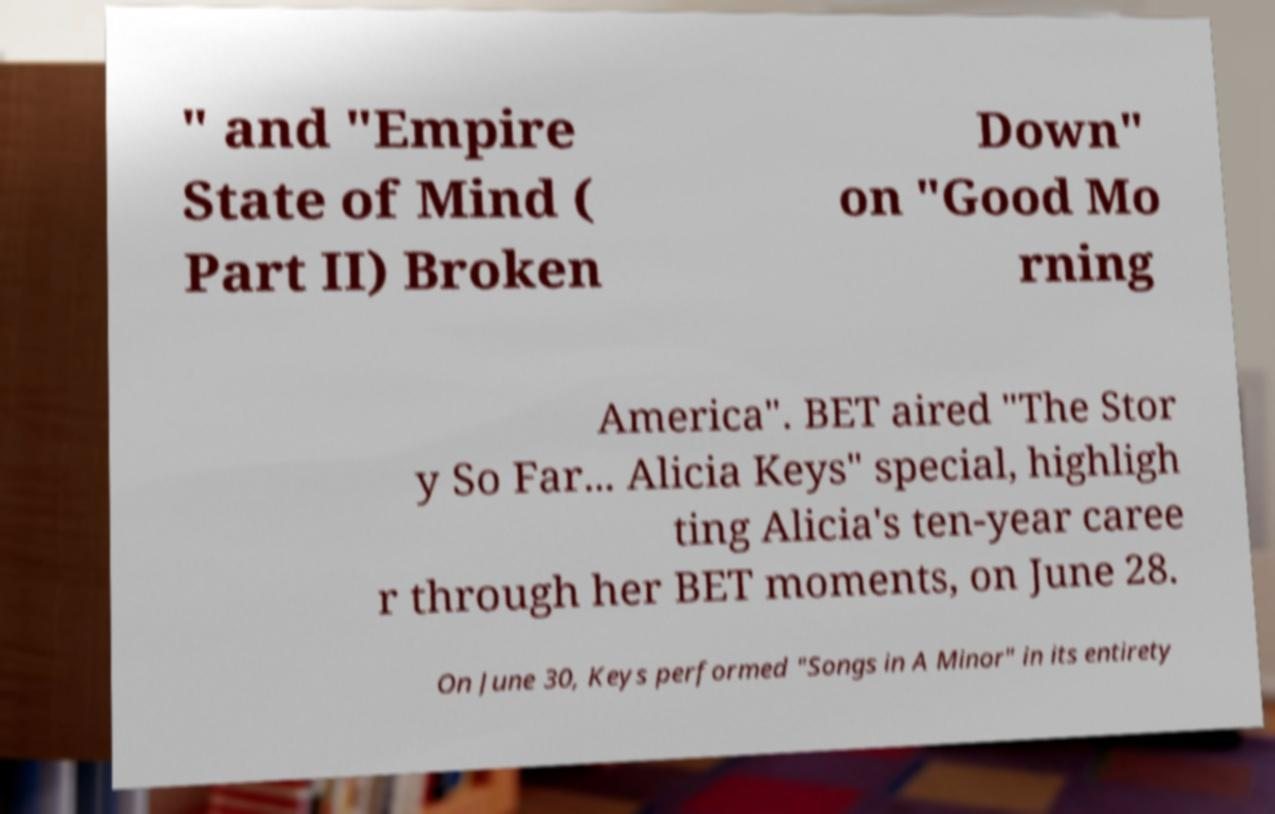For documentation purposes, I need the text within this image transcribed. Could you provide that? " and "Empire State of Mind ( Part II) Broken Down" on "Good Mo rning America". BET aired "The Stor y So Far... Alicia Keys" special, highligh ting Alicia's ten-year caree r through her BET moments, on June 28. On June 30, Keys performed "Songs in A Minor" in its entirety 